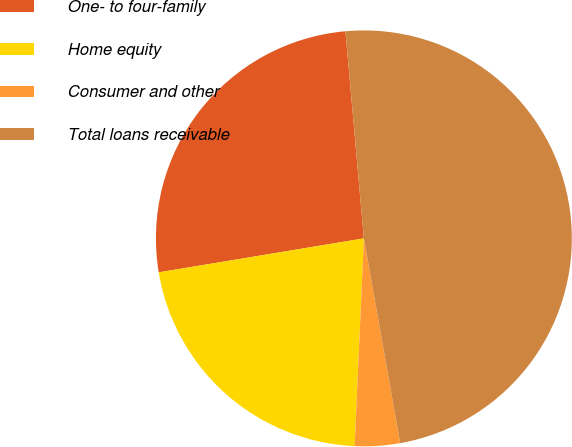<chart> <loc_0><loc_0><loc_500><loc_500><pie_chart><fcel>One- to four-family<fcel>Home equity<fcel>Consumer and other<fcel>Total loans receivable<nl><fcel>26.2%<fcel>21.68%<fcel>3.5%<fcel>48.62%<nl></chart> 